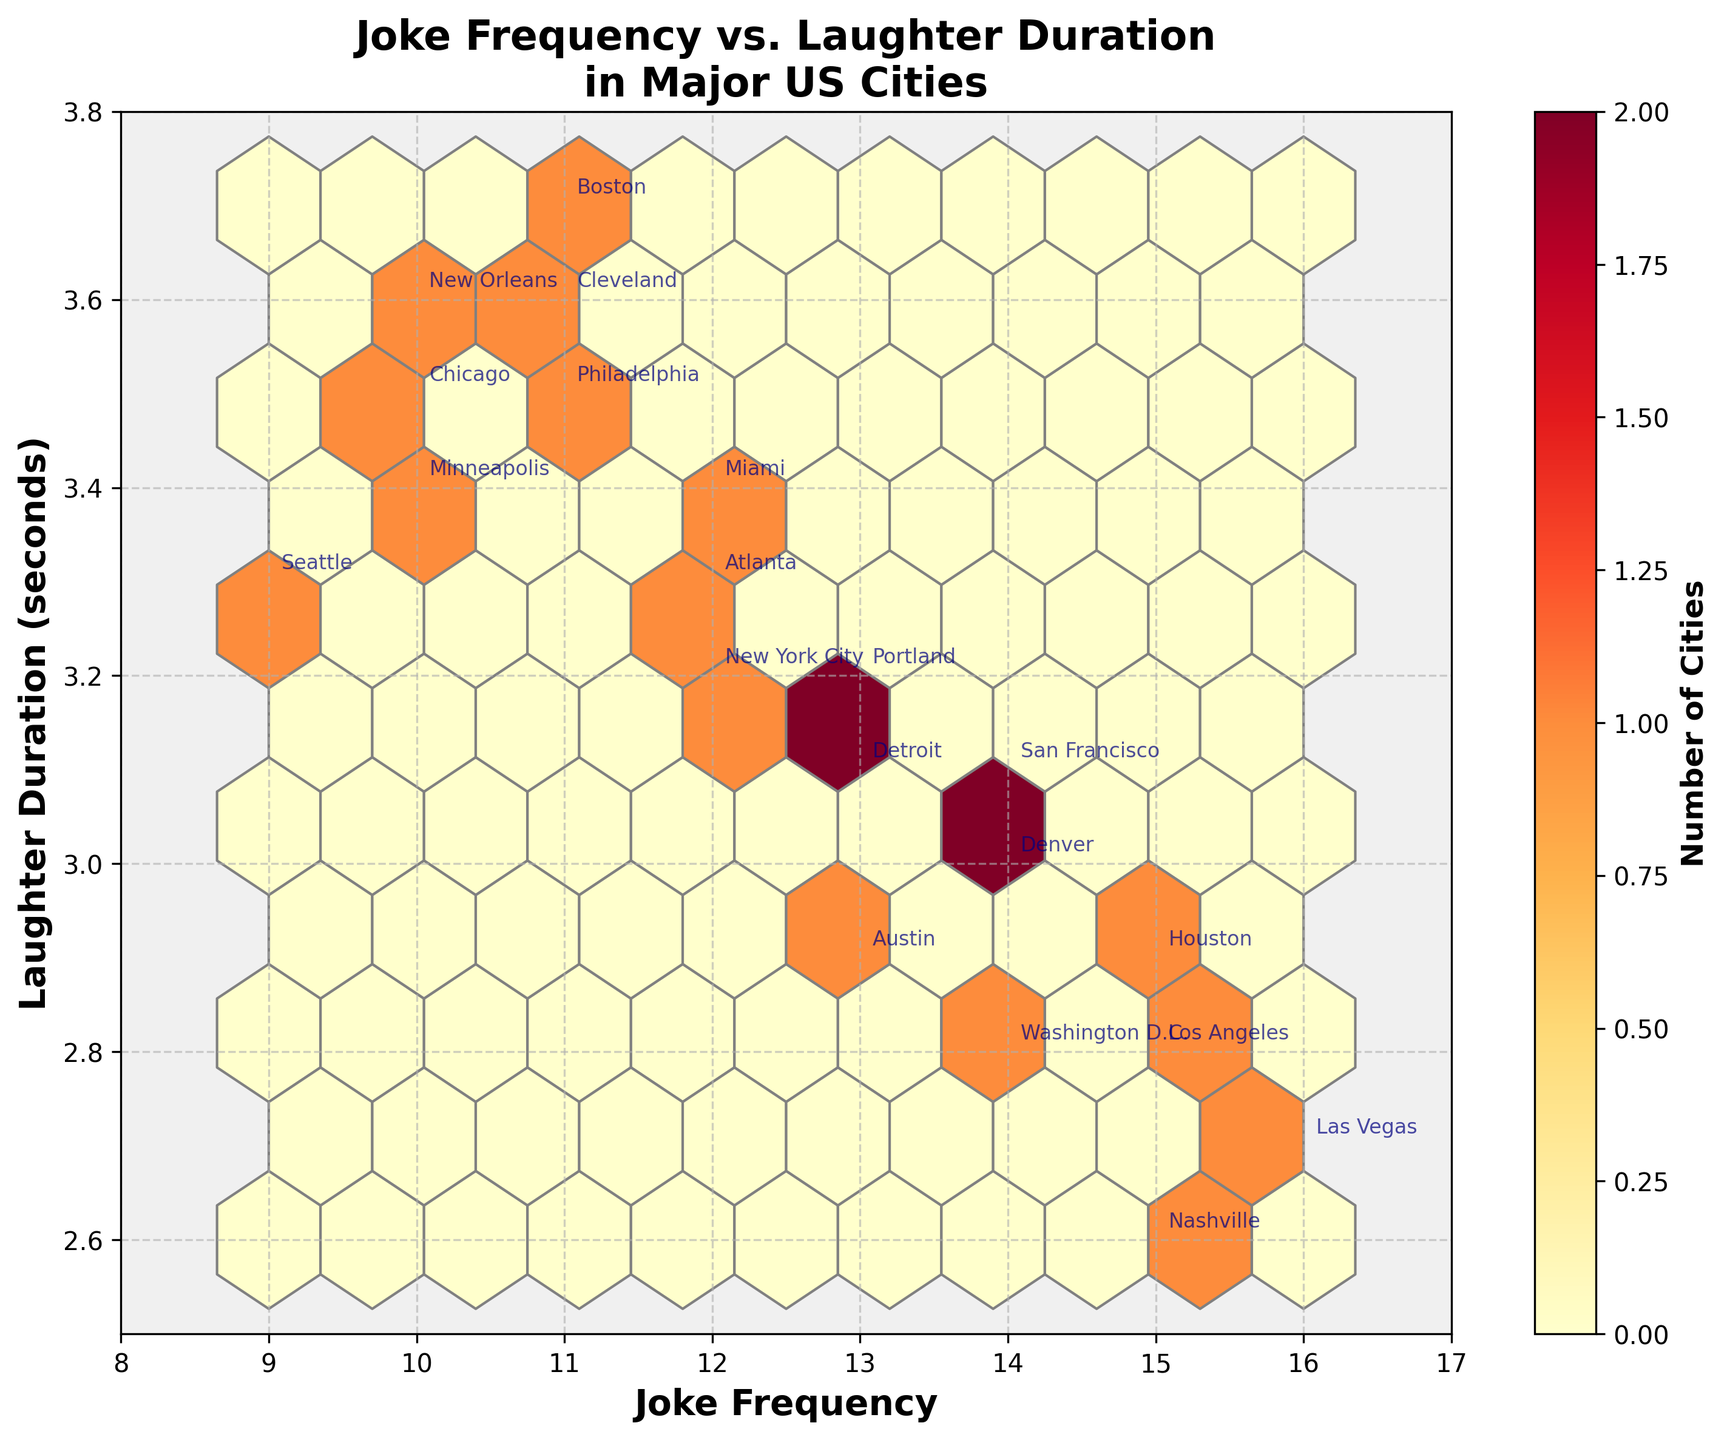What is the title of the hexbin plot? Look at the top of the hexbin plot where the title is usually placed.
Answer: Joke Frequency vs. Laughter Duration in Major US Cities How many total cities are represented in the plot? Count the number of distinct cities labeled on the plot.
Answer: 20 What are the x and y-axis labels of the plot? Refer to the labels provided on the horizontal and vertical axes.
Answer: Joke Frequency and Laughter Duration (seconds) Which city has the highest joke frequency and what is its value? Look for the city label at the edge of the plot with the highest x-axis value.
Answer: Las Vegas, 16 Which city has the lowest laughter duration and what is its value? Identify the city label at the edge of the plot with the lowest y-axis value.
Answer: Nashville, 2.6 How many cities have a joke frequency greater than or equal to 15? Count the number of city labels where the x-axis value is 15 or higher.
Answer: 4 Which cities have both a joke frequency of 11 and a laughter duration of 3.6 seconds? Locate the points where both x-axis and y-axis values match these criteria.
Answer: Cleveland and Philadelphia What does the color intensity represent in the hexbin plot? Identify the meaning of color intensity from the color bar or legend on the plot.
Answer: Number of Cities 